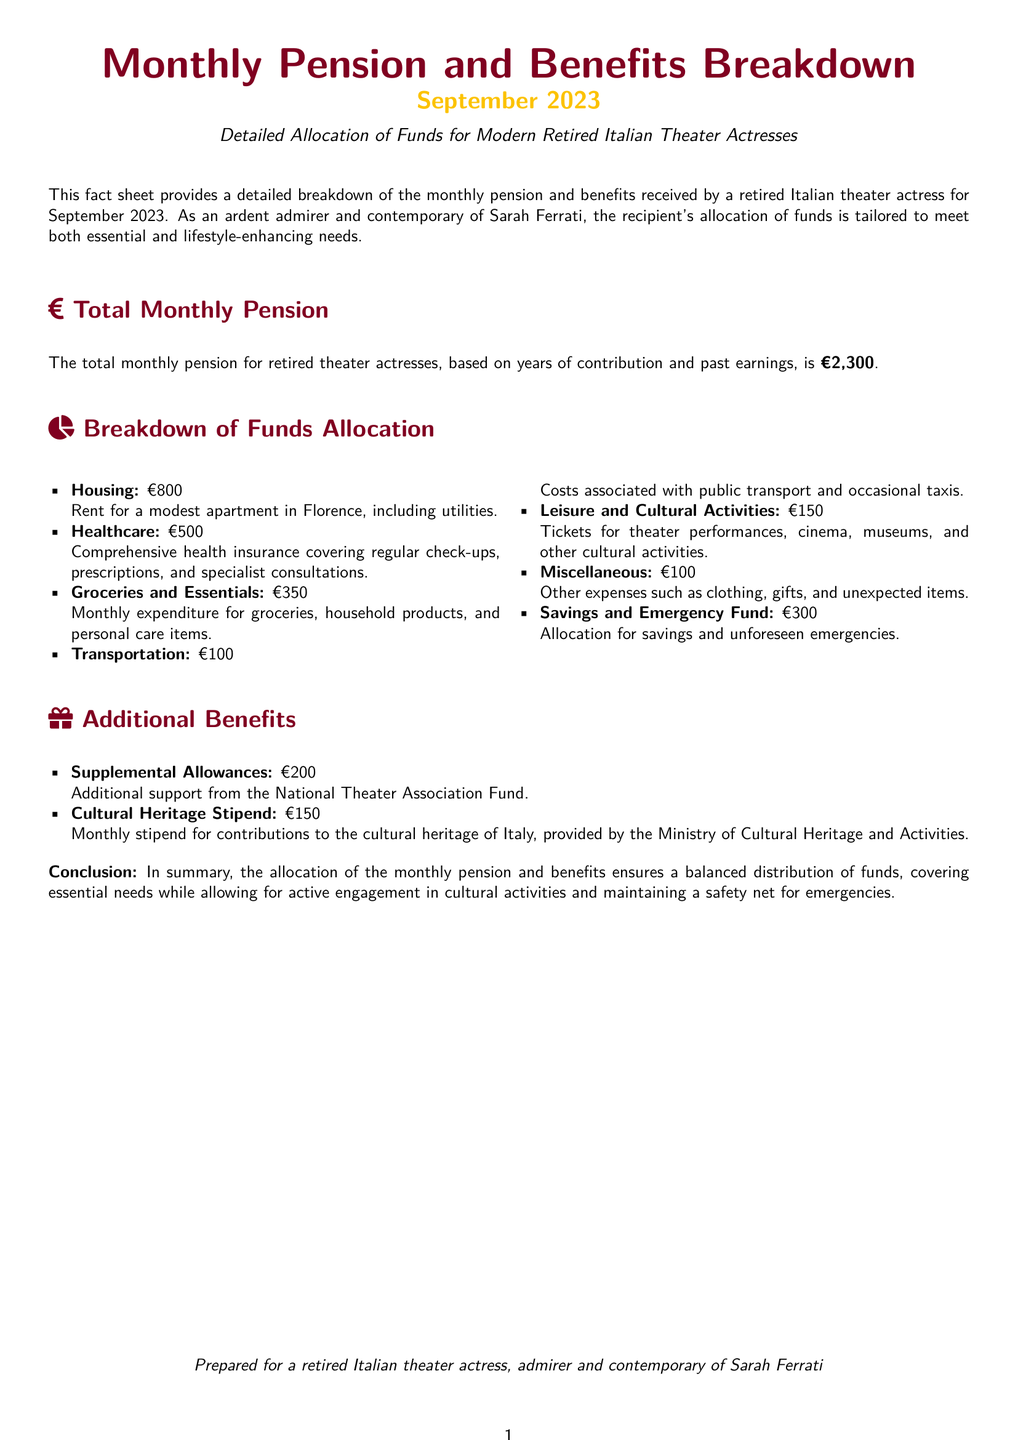what is the total monthly pension? The total monthly pension for retired theater actresses is stated clearly as €2,300.
Answer: €2,300 how much is allocated for housing? The document specifies that €800 is allocated for housing expenses.
Answer: €800 what is the amount for healthcare? The allocation for healthcare is provided as €500 in the document.
Answer: €500 how much is contributed to savings and emergency fund? The document indicates a total of €300 is allocated for savings and emergencies.
Answer: €300 what is the total amount of supplemental allowances? It mentions that the supplemental allowances amount to €200 for additional support.
Answer: €200 how much is allocated for leisure and cultural activities? The document lists €150 as the allocation for leisure and cultural activities.
Answer: €150 what is the cultural heritage stipend amount? The document states that the cultural heritage stipend is €150.
Answer: €150 how is the total monthly pension distributed? The document provides a breakdown indicating essential needs and cultural activities, ensuring a balanced distribution.
Answer: Balanced distribution who prepared the fact sheet? The document is prepared for a retired Italian theater actress, admirer, and contemporary of Sarah Ferrati.
Answer: A retired Italian theater actress 